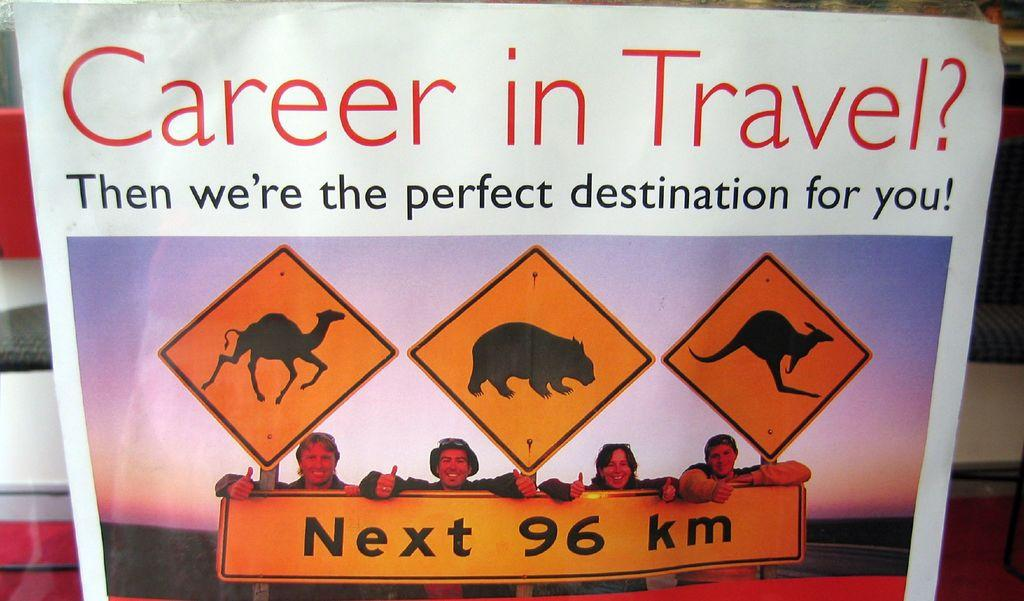<image>
Write a terse but informative summary of the picture. A sign advertises a career in travel showing 4 works standing in front of a road sign featuring pictures of animals. 